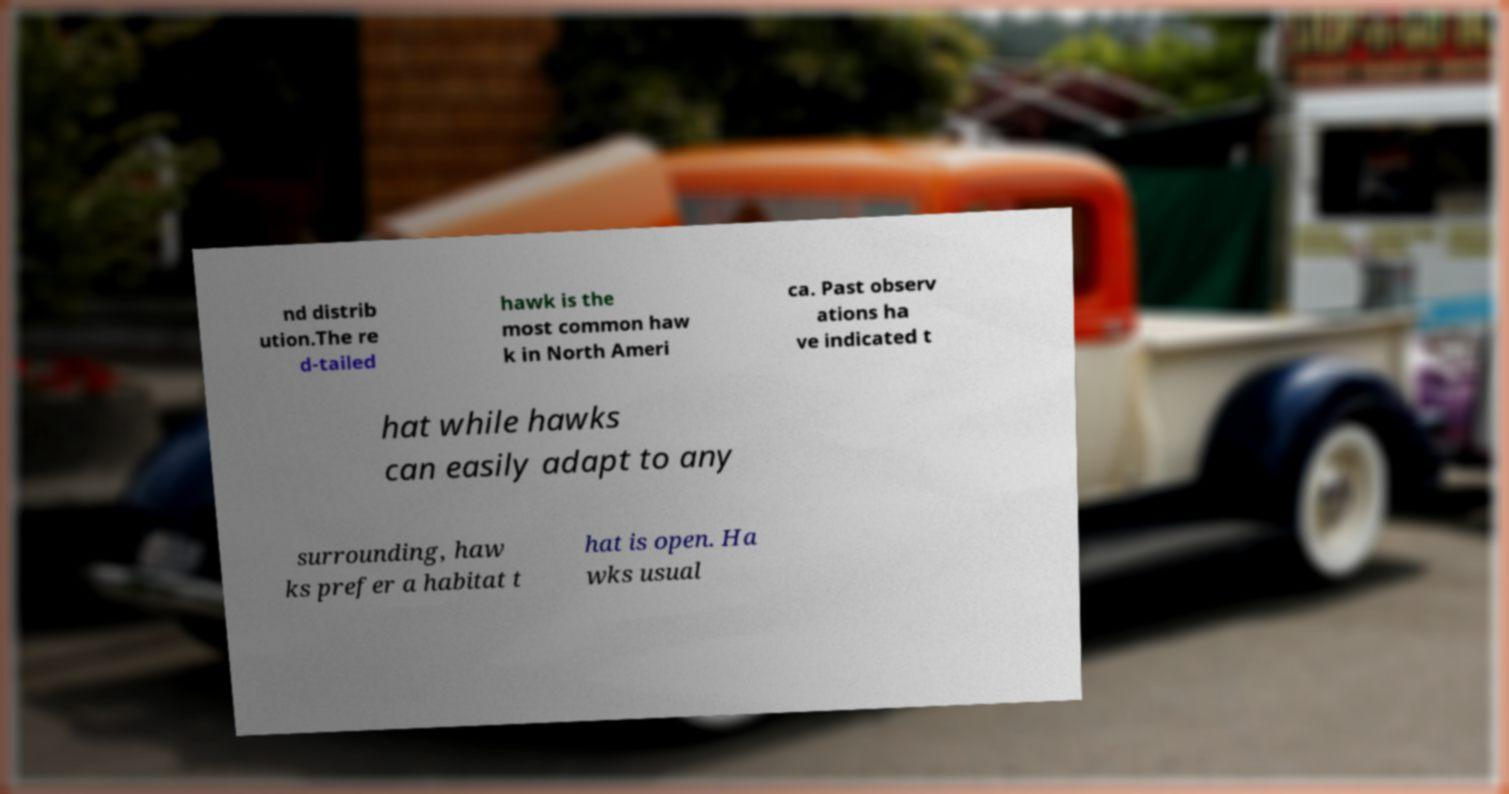For documentation purposes, I need the text within this image transcribed. Could you provide that? nd distrib ution.The re d-tailed hawk is the most common haw k in North Ameri ca. Past observ ations ha ve indicated t hat while hawks can easily adapt to any surrounding, haw ks prefer a habitat t hat is open. Ha wks usual 